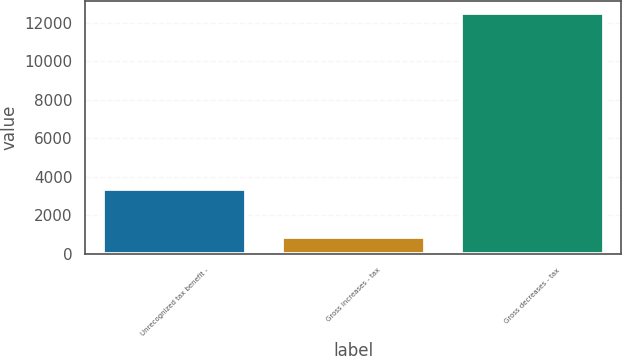Convert chart. <chart><loc_0><loc_0><loc_500><loc_500><bar_chart><fcel>Unrecognized tax benefit -<fcel>Gross increases - tax<fcel>Gross decreases - tax<nl><fcel>3378<fcel>876<fcel>12525<nl></chart> 